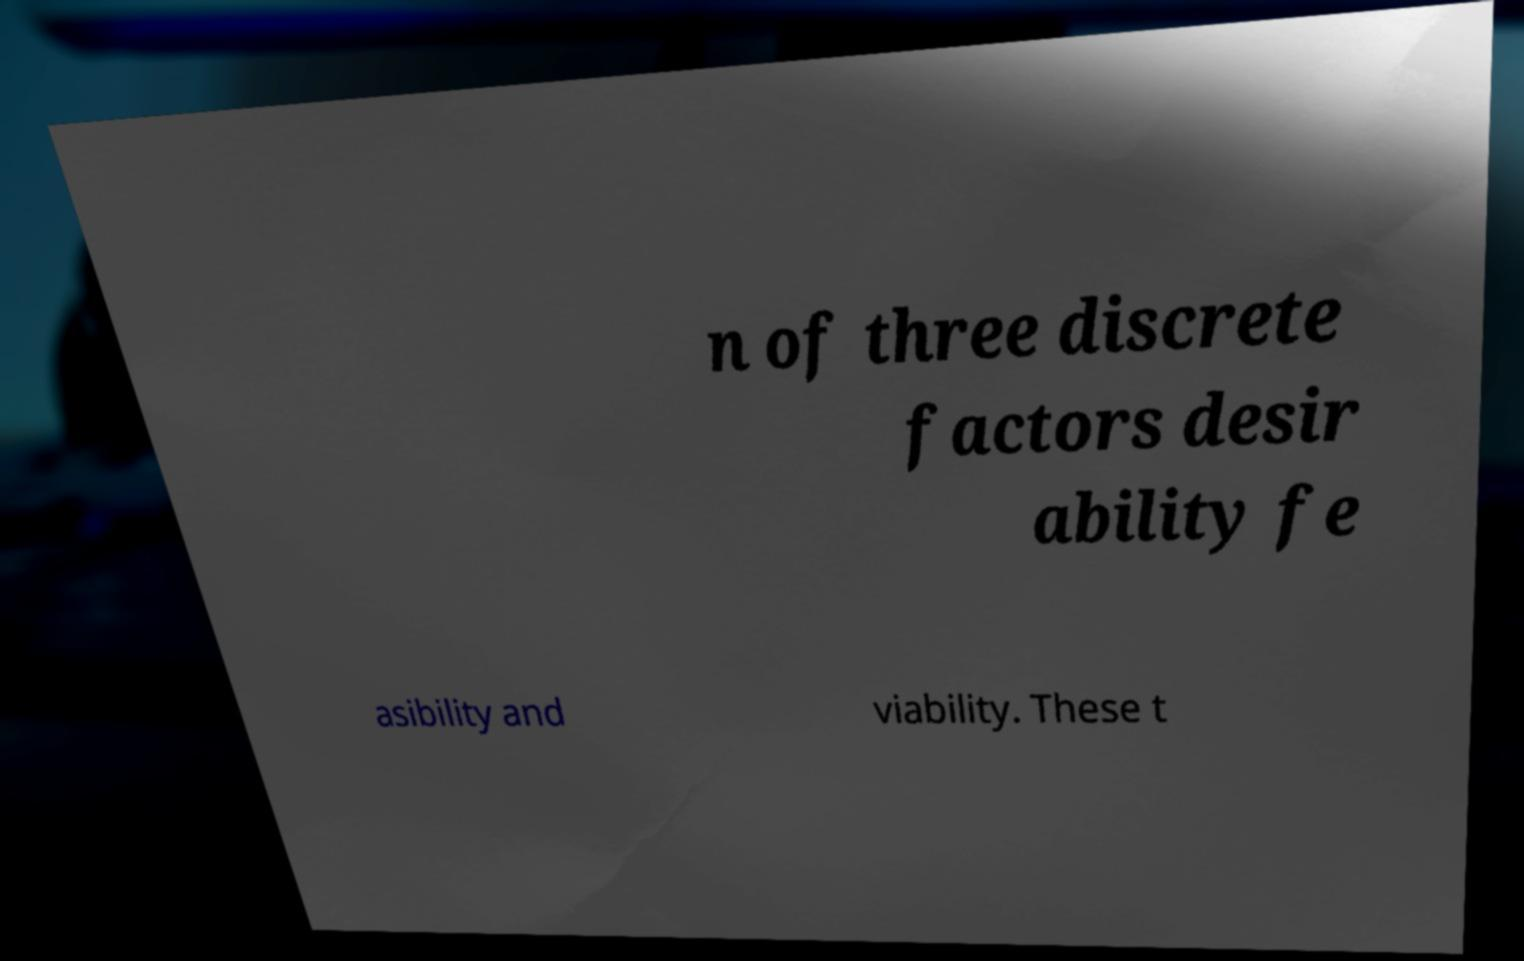For documentation purposes, I need the text within this image transcribed. Could you provide that? n of three discrete factors desir ability fe asibility and viability. These t 